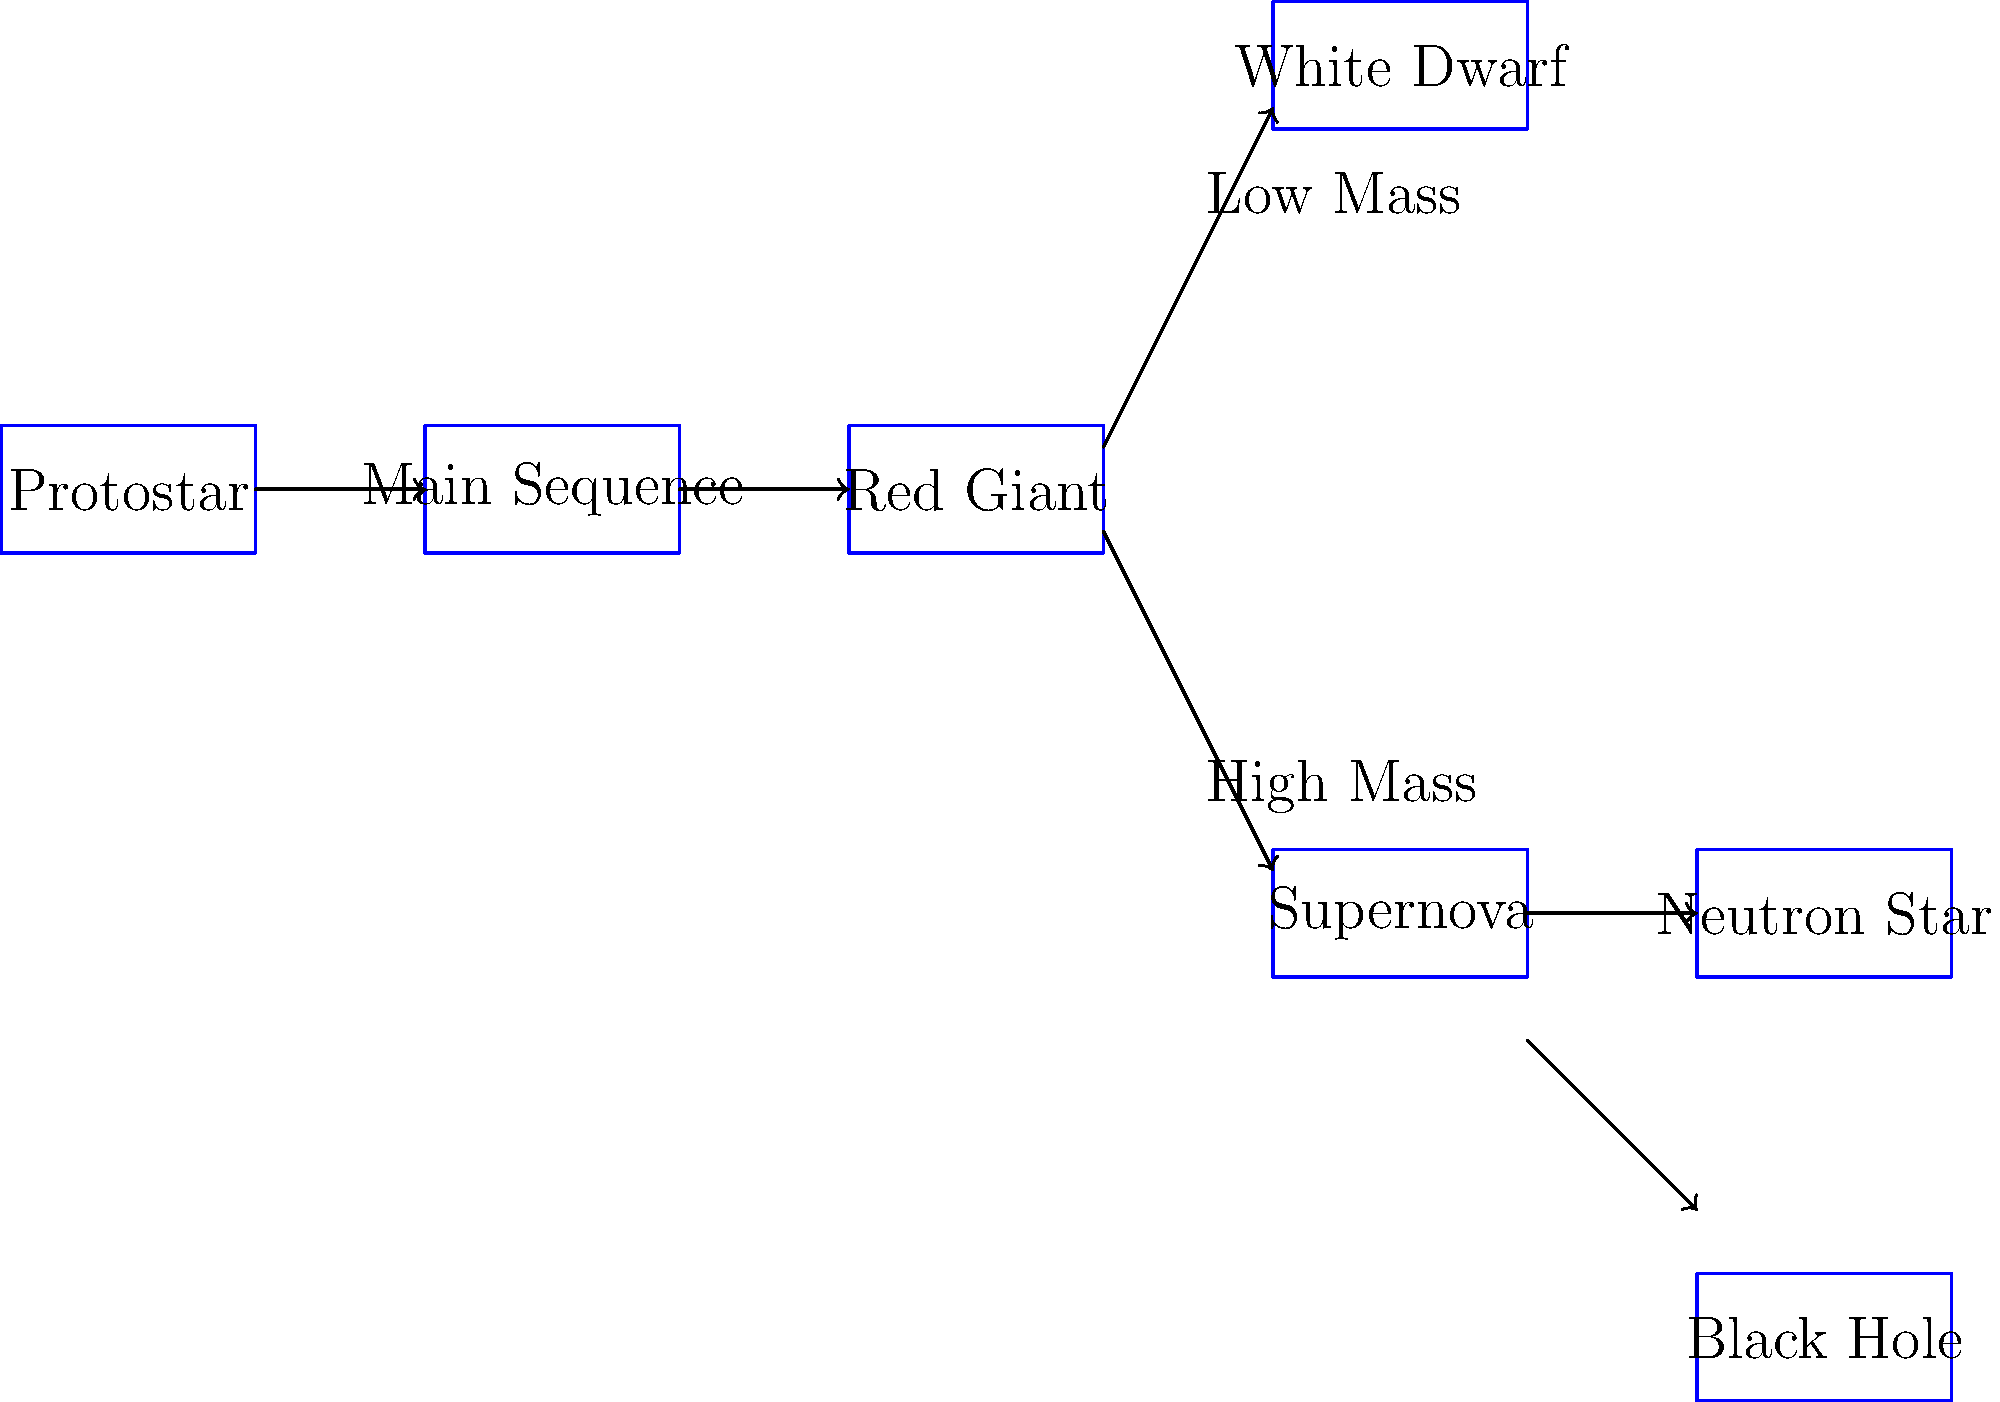Based on the flowchart depicting the life cycle of stars, what determines whether a star will end its life as a white dwarf or undergo a supernova explosion? To answer this question, we need to understand the key factors that influence a star's evolution:

1. The main determinant of a star's fate is its initial mass.

2. All stars begin as protostars and then enter the main sequence phase, where they spend most of their lives fusing hydrogen into helium in their cores.

3. After exhausting the hydrogen in their cores, stars leave the main sequence and become red giants.

4. At this point, the star's mass plays a crucial role in determining its future:

   a. Low-mass stars (roughly $<8M_{\odot}$, where $M_{\odot}$ is the mass of the Sun):
      - These stars don't have enough mass to fuse elements heavier than carbon.
      - They shed their outer layers, forming a planetary nebula.
      - The core contracts to become a white dwarf.

   b. High-mass stars ($\geq 8M_{\odot}$):
      - These stars can fuse heavier elements up to iron in their cores.
      - When fusion can no longer support the star against gravity, it collapses.
      - This collapse triggers a supernova explosion.
      - Depending on the initial mass, the remnant becomes either a neutron star or a black hole.

5. In the flowchart, we can see that after the red giant phase, there's a split:
   - The upper path leads to a white dwarf (low-mass stars).
   - The lower path leads to a supernova, followed by either a neutron star or a black hole (high-mass stars).

Therefore, the initial mass of the star is the key factor that determines whether it will end as a white dwarf or undergo a supernova explosion.
Answer: Initial mass of the star 